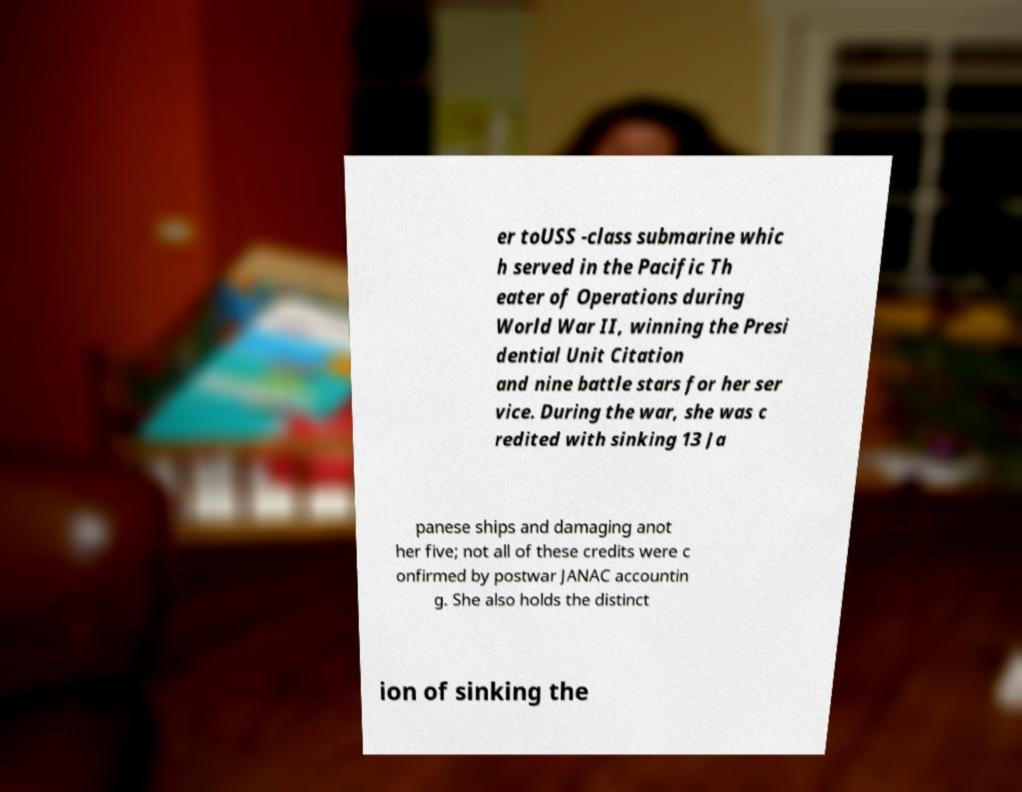Please identify and transcribe the text found in this image. er toUSS -class submarine whic h served in the Pacific Th eater of Operations during World War II, winning the Presi dential Unit Citation and nine battle stars for her ser vice. During the war, she was c redited with sinking 13 Ja panese ships and damaging anot her five; not all of these credits were c onfirmed by postwar JANAC accountin g. She also holds the distinct ion of sinking the 